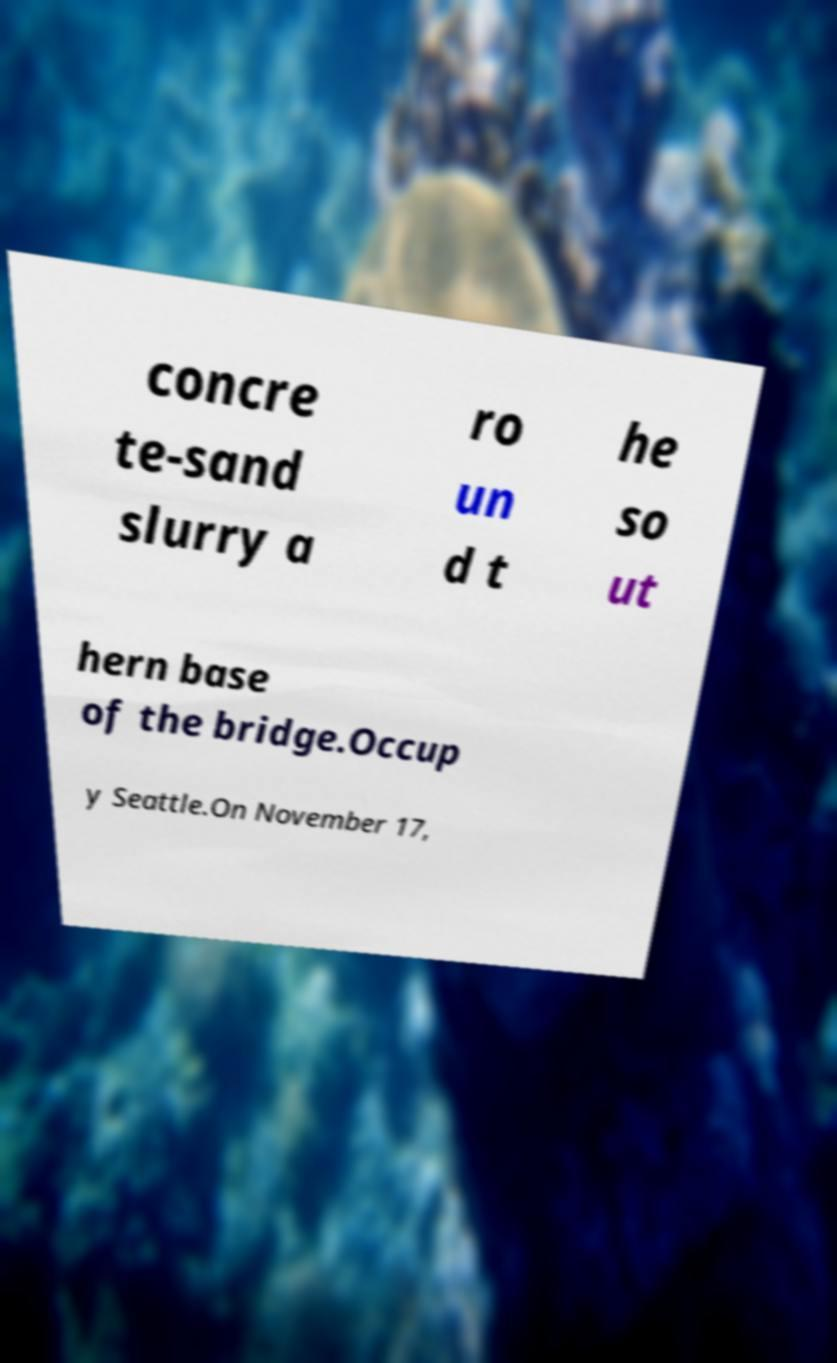Can you read and provide the text displayed in the image?This photo seems to have some interesting text. Can you extract and type it out for me? concre te-sand slurry a ro un d t he so ut hern base of the bridge.Occup y Seattle.On November 17, 